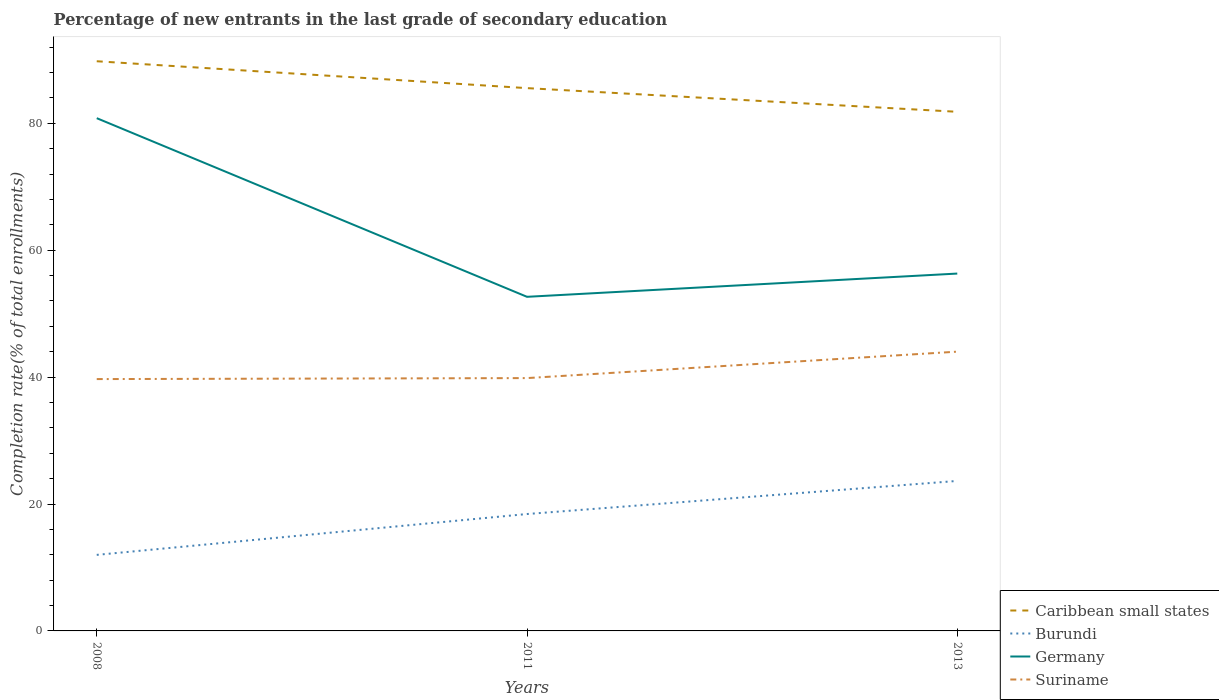Does the line corresponding to Germany intersect with the line corresponding to Suriname?
Offer a terse response. No. Across all years, what is the maximum percentage of new entrants in Suriname?
Your answer should be compact. 39.69. In which year was the percentage of new entrants in Germany maximum?
Ensure brevity in your answer.  2011. What is the total percentage of new entrants in Burundi in the graph?
Your response must be concise. -11.65. What is the difference between the highest and the second highest percentage of new entrants in Suriname?
Make the answer very short. 4.32. How many lines are there?
Your response must be concise. 4. How many years are there in the graph?
Offer a very short reply. 3. Are the values on the major ticks of Y-axis written in scientific E-notation?
Offer a terse response. No. Does the graph contain any zero values?
Give a very brief answer. No. Does the graph contain grids?
Offer a very short reply. No. How are the legend labels stacked?
Your response must be concise. Vertical. What is the title of the graph?
Keep it short and to the point. Percentage of new entrants in the last grade of secondary education. Does "Malaysia" appear as one of the legend labels in the graph?
Ensure brevity in your answer.  No. What is the label or title of the Y-axis?
Your answer should be compact. Completion rate(% of total enrollments). What is the Completion rate(% of total enrollments) in Caribbean small states in 2008?
Give a very brief answer. 89.77. What is the Completion rate(% of total enrollments) in Burundi in 2008?
Your answer should be compact. 11.98. What is the Completion rate(% of total enrollments) in Germany in 2008?
Make the answer very short. 80.8. What is the Completion rate(% of total enrollments) of Suriname in 2008?
Keep it short and to the point. 39.69. What is the Completion rate(% of total enrollments) in Caribbean small states in 2011?
Your response must be concise. 85.54. What is the Completion rate(% of total enrollments) of Burundi in 2011?
Ensure brevity in your answer.  18.42. What is the Completion rate(% of total enrollments) in Germany in 2011?
Your answer should be very brief. 52.65. What is the Completion rate(% of total enrollments) in Suriname in 2011?
Give a very brief answer. 39.84. What is the Completion rate(% of total enrollments) of Caribbean small states in 2013?
Ensure brevity in your answer.  81.81. What is the Completion rate(% of total enrollments) in Burundi in 2013?
Provide a succinct answer. 23.64. What is the Completion rate(% of total enrollments) in Germany in 2013?
Provide a short and direct response. 56.32. What is the Completion rate(% of total enrollments) in Suriname in 2013?
Your answer should be compact. 44.01. Across all years, what is the maximum Completion rate(% of total enrollments) of Caribbean small states?
Provide a short and direct response. 89.77. Across all years, what is the maximum Completion rate(% of total enrollments) of Burundi?
Your answer should be very brief. 23.64. Across all years, what is the maximum Completion rate(% of total enrollments) in Germany?
Your answer should be compact. 80.8. Across all years, what is the maximum Completion rate(% of total enrollments) of Suriname?
Your answer should be compact. 44.01. Across all years, what is the minimum Completion rate(% of total enrollments) of Caribbean small states?
Provide a short and direct response. 81.81. Across all years, what is the minimum Completion rate(% of total enrollments) of Burundi?
Your answer should be very brief. 11.98. Across all years, what is the minimum Completion rate(% of total enrollments) of Germany?
Offer a terse response. 52.65. Across all years, what is the minimum Completion rate(% of total enrollments) in Suriname?
Your response must be concise. 39.69. What is the total Completion rate(% of total enrollments) in Caribbean small states in the graph?
Your response must be concise. 257.12. What is the total Completion rate(% of total enrollments) in Burundi in the graph?
Provide a short and direct response. 54.04. What is the total Completion rate(% of total enrollments) of Germany in the graph?
Your response must be concise. 189.78. What is the total Completion rate(% of total enrollments) of Suriname in the graph?
Offer a terse response. 123.54. What is the difference between the Completion rate(% of total enrollments) of Caribbean small states in 2008 and that in 2011?
Your answer should be compact. 4.23. What is the difference between the Completion rate(% of total enrollments) of Burundi in 2008 and that in 2011?
Keep it short and to the point. -6.44. What is the difference between the Completion rate(% of total enrollments) of Germany in 2008 and that in 2011?
Provide a succinct answer. 28.15. What is the difference between the Completion rate(% of total enrollments) in Suriname in 2008 and that in 2011?
Ensure brevity in your answer.  -0.16. What is the difference between the Completion rate(% of total enrollments) of Caribbean small states in 2008 and that in 2013?
Provide a succinct answer. 7.96. What is the difference between the Completion rate(% of total enrollments) of Burundi in 2008 and that in 2013?
Offer a terse response. -11.65. What is the difference between the Completion rate(% of total enrollments) in Germany in 2008 and that in 2013?
Your answer should be very brief. 24.49. What is the difference between the Completion rate(% of total enrollments) of Suriname in 2008 and that in 2013?
Provide a short and direct response. -4.32. What is the difference between the Completion rate(% of total enrollments) of Caribbean small states in 2011 and that in 2013?
Give a very brief answer. 3.73. What is the difference between the Completion rate(% of total enrollments) in Burundi in 2011 and that in 2013?
Provide a succinct answer. -5.22. What is the difference between the Completion rate(% of total enrollments) of Germany in 2011 and that in 2013?
Offer a very short reply. -3.66. What is the difference between the Completion rate(% of total enrollments) of Suriname in 2011 and that in 2013?
Your answer should be compact. -4.17. What is the difference between the Completion rate(% of total enrollments) in Caribbean small states in 2008 and the Completion rate(% of total enrollments) in Burundi in 2011?
Offer a terse response. 71.35. What is the difference between the Completion rate(% of total enrollments) in Caribbean small states in 2008 and the Completion rate(% of total enrollments) in Germany in 2011?
Your response must be concise. 37.12. What is the difference between the Completion rate(% of total enrollments) of Caribbean small states in 2008 and the Completion rate(% of total enrollments) of Suriname in 2011?
Ensure brevity in your answer.  49.93. What is the difference between the Completion rate(% of total enrollments) of Burundi in 2008 and the Completion rate(% of total enrollments) of Germany in 2011?
Provide a short and direct response. -40.67. What is the difference between the Completion rate(% of total enrollments) of Burundi in 2008 and the Completion rate(% of total enrollments) of Suriname in 2011?
Provide a short and direct response. -27.86. What is the difference between the Completion rate(% of total enrollments) of Germany in 2008 and the Completion rate(% of total enrollments) of Suriname in 2011?
Give a very brief answer. 40.96. What is the difference between the Completion rate(% of total enrollments) of Caribbean small states in 2008 and the Completion rate(% of total enrollments) of Burundi in 2013?
Your response must be concise. 66.14. What is the difference between the Completion rate(% of total enrollments) in Caribbean small states in 2008 and the Completion rate(% of total enrollments) in Germany in 2013?
Keep it short and to the point. 33.46. What is the difference between the Completion rate(% of total enrollments) of Caribbean small states in 2008 and the Completion rate(% of total enrollments) of Suriname in 2013?
Provide a short and direct response. 45.76. What is the difference between the Completion rate(% of total enrollments) of Burundi in 2008 and the Completion rate(% of total enrollments) of Germany in 2013?
Ensure brevity in your answer.  -44.33. What is the difference between the Completion rate(% of total enrollments) in Burundi in 2008 and the Completion rate(% of total enrollments) in Suriname in 2013?
Make the answer very short. -32.03. What is the difference between the Completion rate(% of total enrollments) in Germany in 2008 and the Completion rate(% of total enrollments) in Suriname in 2013?
Provide a short and direct response. 36.79. What is the difference between the Completion rate(% of total enrollments) in Caribbean small states in 2011 and the Completion rate(% of total enrollments) in Burundi in 2013?
Give a very brief answer. 61.9. What is the difference between the Completion rate(% of total enrollments) in Caribbean small states in 2011 and the Completion rate(% of total enrollments) in Germany in 2013?
Provide a succinct answer. 29.22. What is the difference between the Completion rate(% of total enrollments) in Caribbean small states in 2011 and the Completion rate(% of total enrollments) in Suriname in 2013?
Provide a succinct answer. 41.53. What is the difference between the Completion rate(% of total enrollments) of Burundi in 2011 and the Completion rate(% of total enrollments) of Germany in 2013?
Ensure brevity in your answer.  -37.9. What is the difference between the Completion rate(% of total enrollments) in Burundi in 2011 and the Completion rate(% of total enrollments) in Suriname in 2013?
Your answer should be very brief. -25.59. What is the difference between the Completion rate(% of total enrollments) of Germany in 2011 and the Completion rate(% of total enrollments) of Suriname in 2013?
Your answer should be compact. 8.64. What is the average Completion rate(% of total enrollments) in Caribbean small states per year?
Your answer should be very brief. 85.71. What is the average Completion rate(% of total enrollments) of Burundi per year?
Make the answer very short. 18.01. What is the average Completion rate(% of total enrollments) in Germany per year?
Provide a succinct answer. 63.26. What is the average Completion rate(% of total enrollments) of Suriname per year?
Offer a very short reply. 41.18. In the year 2008, what is the difference between the Completion rate(% of total enrollments) in Caribbean small states and Completion rate(% of total enrollments) in Burundi?
Offer a terse response. 77.79. In the year 2008, what is the difference between the Completion rate(% of total enrollments) in Caribbean small states and Completion rate(% of total enrollments) in Germany?
Your answer should be very brief. 8.97. In the year 2008, what is the difference between the Completion rate(% of total enrollments) in Caribbean small states and Completion rate(% of total enrollments) in Suriname?
Offer a terse response. 50.09. In the year 2008, what is the difference between the Completion rate(% of total enrollments) of Burundi and Completion rate(% of total enrollments) of Germany?
Give a very brief answer. -68.82. In the year 2008, what is the difference between the Completion rate(% of total enrollments) of Burundi and Completion rate(% of total enrollments) of Suriname?
Provide a short and direct response. -27.7. In the year 2008, what is the difference between the Completion rate(% of total enrollments) of Germany and Completion rate(% of total enrollments) of Suriname?
Offer a terse response. 41.12. In the year 2011, what is the difference between the Completion rate(% of total enrollments) of Caribbean small states and Completion rate(% of total enrollments) of Burundi?
Your answer should be compact. 67.12. In the year 2011, what is the difference between the Completion rate(% of total enrollments) in Caribbean small states and Completion rate(% of total enrollments) in Germany?
Your answer should be compact. 32.89. In the year 2011, what is the difference between the Completion rate(% of total enrollments) of Caribbean small states and Completion rate(% of total enrollments) of Suriname?
Your answer should be compact. 45.7. In the year 2011, what is the difference between the Completion rate(% of total enrollments) in Burundi and Completion rate(% of total enrollments) in Germany?
Offer a terse response. -34.23. In the year 2011, what is the difference between the Completion rate(% of total enrollments) of Burundi and Completion rate(% of total enrollments) of Suriname?
Ensure brevity in your answer.  -21.42. In the year 2011, what is the difference between the Completion rate(% of total enrollments) in Germany and Completion rate(% of total enrollments) in Suriname?
Give a very brief answer. 12.81. In the year 2013, what is the difference between the Completion rate(% of total enrollments) of Caribbean small states and Completion rate(% of total enrollments) of Burundi?
Provide a short and direct response. 58.17. In the year 2013, what is the difference between the Completion rate(% of total enrollments) of Caribbean small states and Completion rate(% of total enrollments) of Germany?
Provide a short and direct response. 25.49. In the year 2013, what is the difference between the Completion rate(% of total enrollments) in Caribbean small states and Completion rate(% of total enrollments) in Suriname?
Make the answer very short. 37.8. In the year 2013, what is the difference between the Completion rate(% of total enrollments) of Burundi and Completion rate(% of total enrollments) of Germany?
Ensure brevity in your answer.  -32.68. In the year 2013, what is the difference between the Completion rate(% of total enrollments) of Burundi and Completion rate(% of total enrollments) of Suriname?
Your answer should be compact. -20.37. In the year 2013, what is the difference between the Completion rate(% of total enrollments) of Germany and Completion rate(% of total enrollments) of Suriname?
Make the answer very short. 12.31. What is the ratio of the Completion rate(% of total enrollments) in Caribbean small states in 2008 to that in 2011?
Provide a succinct answer. 1.05. What is the ratio of the Completion rate(% of total enrollments) of Burundi in 2008 to that in 2011?
Provide a short and direct response. 0.65. What is the ratio of the Completion rate(% of total enrollments) of Germany in 2008 to that in 2011?
Your answer should be compact. 1.53. What is the ratio of the Completion rate(% of total enrollments) of Suriname in 2008 to that in 2011?
Offer a very short reply. 1. What is the ratio of the Completion rate(% of total enrollments) in Caribbean small states in 2008 to that in 2013?
Ensure brevity in your answer.  1.1. What is the ratio of the Completion rate(% of total enrollments) in Burundi in 2008 to that in 2013?
Ensure brevity in your answer.  0.51. What is the ratio of the Completion rate(% of total enrollments) of Germany in 2008 to that in 2013?
Give a very brief answer. 1.43. What is the ratio of the Completion rate(% of total enrollments) of Suriname in 2008 to that in 2013?
Provide a succinct answer. 0.9. What is the ratio of the Completion rate(% of total enrollments) in Caribbean small states in 2011 to that in 2013?
Provide a short and direct response. 1.05. What is the ratio of the Completion rate(% of total enrollments) in Burundi in 2011 to that in 2013?
Your response must be concise. 0.78. What is the ratio of the Completion rate(% of total enrollments) in Germany in 2011 to that in 2013?
Make the answer very short. 0.94. What is the ratio of the Completion rate(% of total enrollments) of Suriname in 2011 to that in 2013?
Offer a very short reply. 0.91. What is the difference between the highest and the second highest Completion rate(% of total enrollments) in Caribbean small states?
Your response must be concise. 4.23. What is the difference between the highest and the second highest Completion rate(% of total enrollments) in Burundi?
Your answer should be very brief. 5.22. What is the difference between the highest and the second highest Completion rate(% of total enrollments) in Germany?
Provide a succinct answer. 24.49. What is the difference between the highest and the second highest Completion rate(% of total enrollments) of Suriname?
Offer a very short reply. 4.17. What is the difference between the highest and the lowest Completion rate(% of total enrollments) of Caribbean small states?
Offer a very short reply. 7.96. What is the difference between the highest and the lowest Completion rate(% of total enrollments) of Burundi?
Make the answer very short. 11.65. What is the difference between the highest and the lowest Completion rate(% of total enrollments) in Germany?
Ensure brevity in your answer.  28.15. What is the difference between the highest and the lowest Completion rate(% of total enrollments) in Suriname?
Keep it short and to the point. 4.32. 